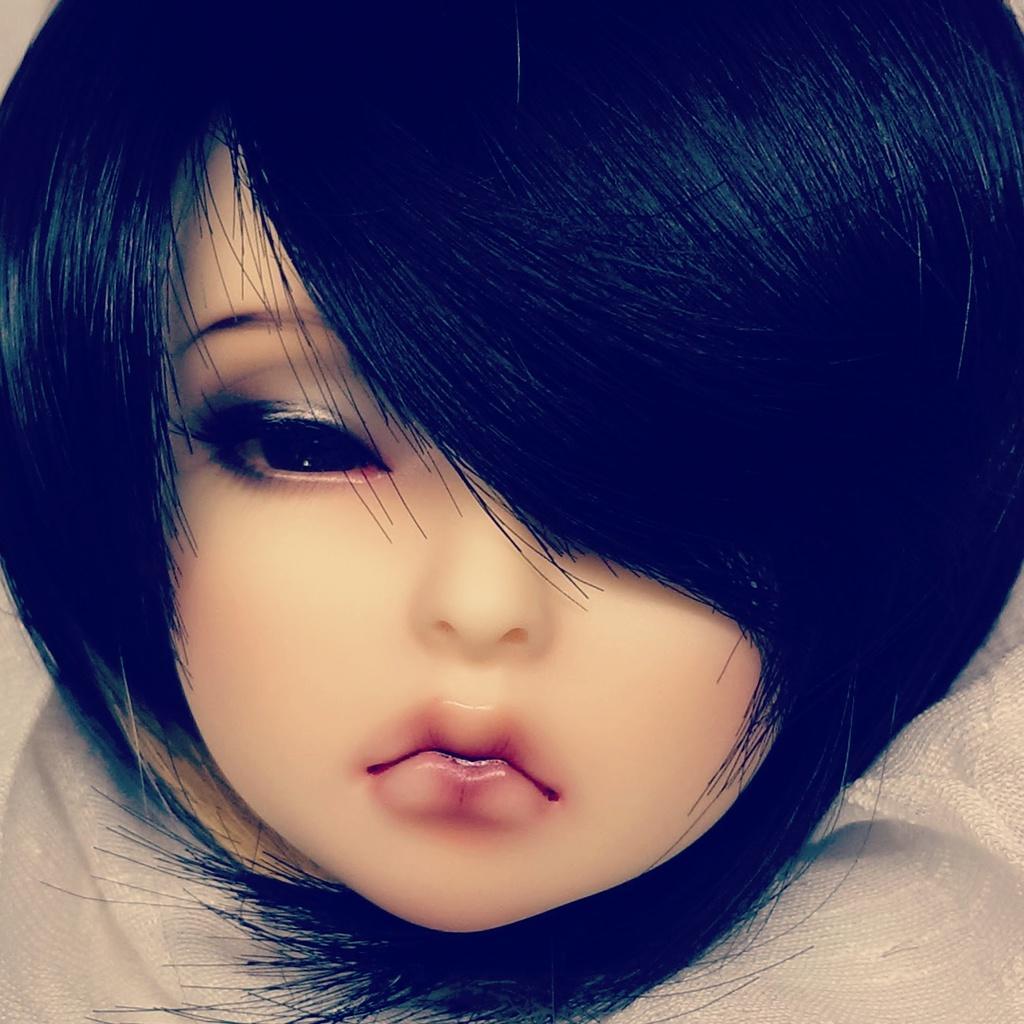Please provide a concise description of this image. In this picture it is looking like an animated picture of a baby. 